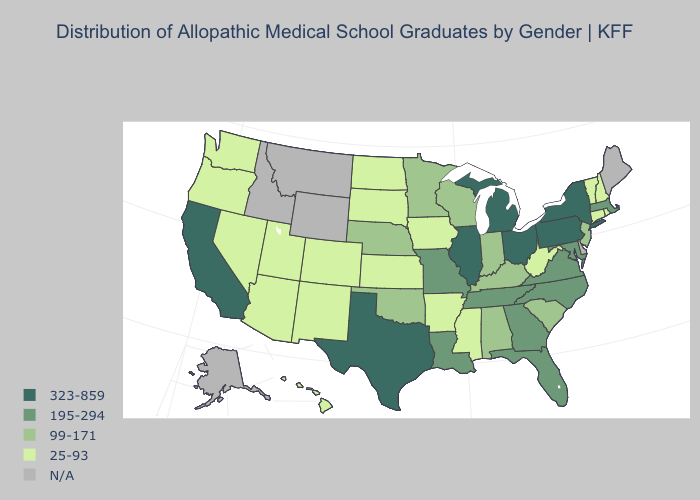What is the lowest value in states that border New York?
Short answer required. 25-93. Which states have the highest value in the USA?
Short answer required. California, Illinois, Michigan, New York, Ohio, Pennsylvania, Texas. What is the highest value in the South ?
Give a very brief answer. 323-859. What is the value of Washington?
Keep it brief. 25-93. How many symbols are there in the legend?
Give a very brief answer. 5. Does the map have missing data?
Write a very short answer. Yes. Name the states that have a value in the range 25-93?
Quick response, please. Arizona, Arkansas, Colorado, Connecticut, Hawaii, Iowa, Kansas, Mississippi, Nevada, New Hampshire, New Mexico, North Dakota, Oregon, Rhode Island, South Dakota, Utah, Vermont, Washington, West Virginia. Does the map have missing data?
Be succinct. Yes. What is the value of Utah?
Concise answer only. 25-93. Name the states that have a value in the range 99-171?
Be succinct. Alabama, Indiana, Kentucky, Minnesota, Nebraska, New Jersey, Oklahoma, South Carolina, Wisconsin. What is the highest value in the West ?
Short answer required. 323-859. How many symbols are there in the legend?
Quick response, please. 5. Which states have the lowest value in the MidWest?
Answer briefly. Iowa, Kansas, North Dakota, South Dakota. 